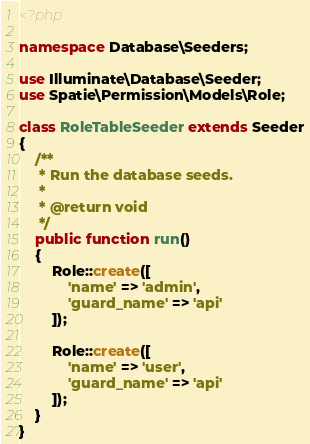Convert code to text. <code><loc_0><loc_0><loc_500><loc_500><_PHP_><?php

namespace Database\Seeders;

use Illuminate\Database\Seeder;
use Spatie\Permission\Models\Role;

class RoleTableSeeder extends Seeder
{
    /**
     * Run the database seeds.
     *
     * @return void
     */
    public function run()
    {
        Role::create([
            'name' => 'admin',
            'guard_name' => 'api'
        ]);

        Role::create([
            'name' => 'user',
            'guard_name' => 'api'
        ]);
    }
}
</code> 